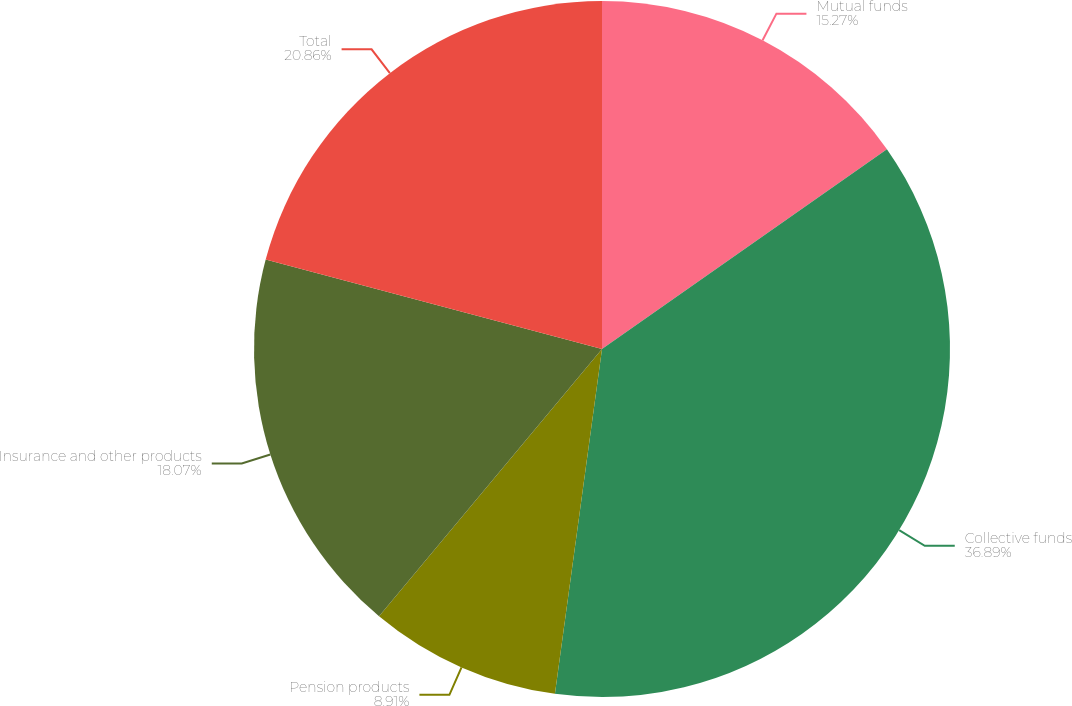<chart> <loc_0><loc_0><loc_500><loc_500><pie_chart><fcel>Mutual funds<fcel>Collective funds<fcel>Pension products<fcel>Insurance and other products<fcel>Total<nl><fcel>15.27%<fcel>36.9%<fcel>8.91%<fcel>18.07%<fcel>20.87%<nl></chart> 